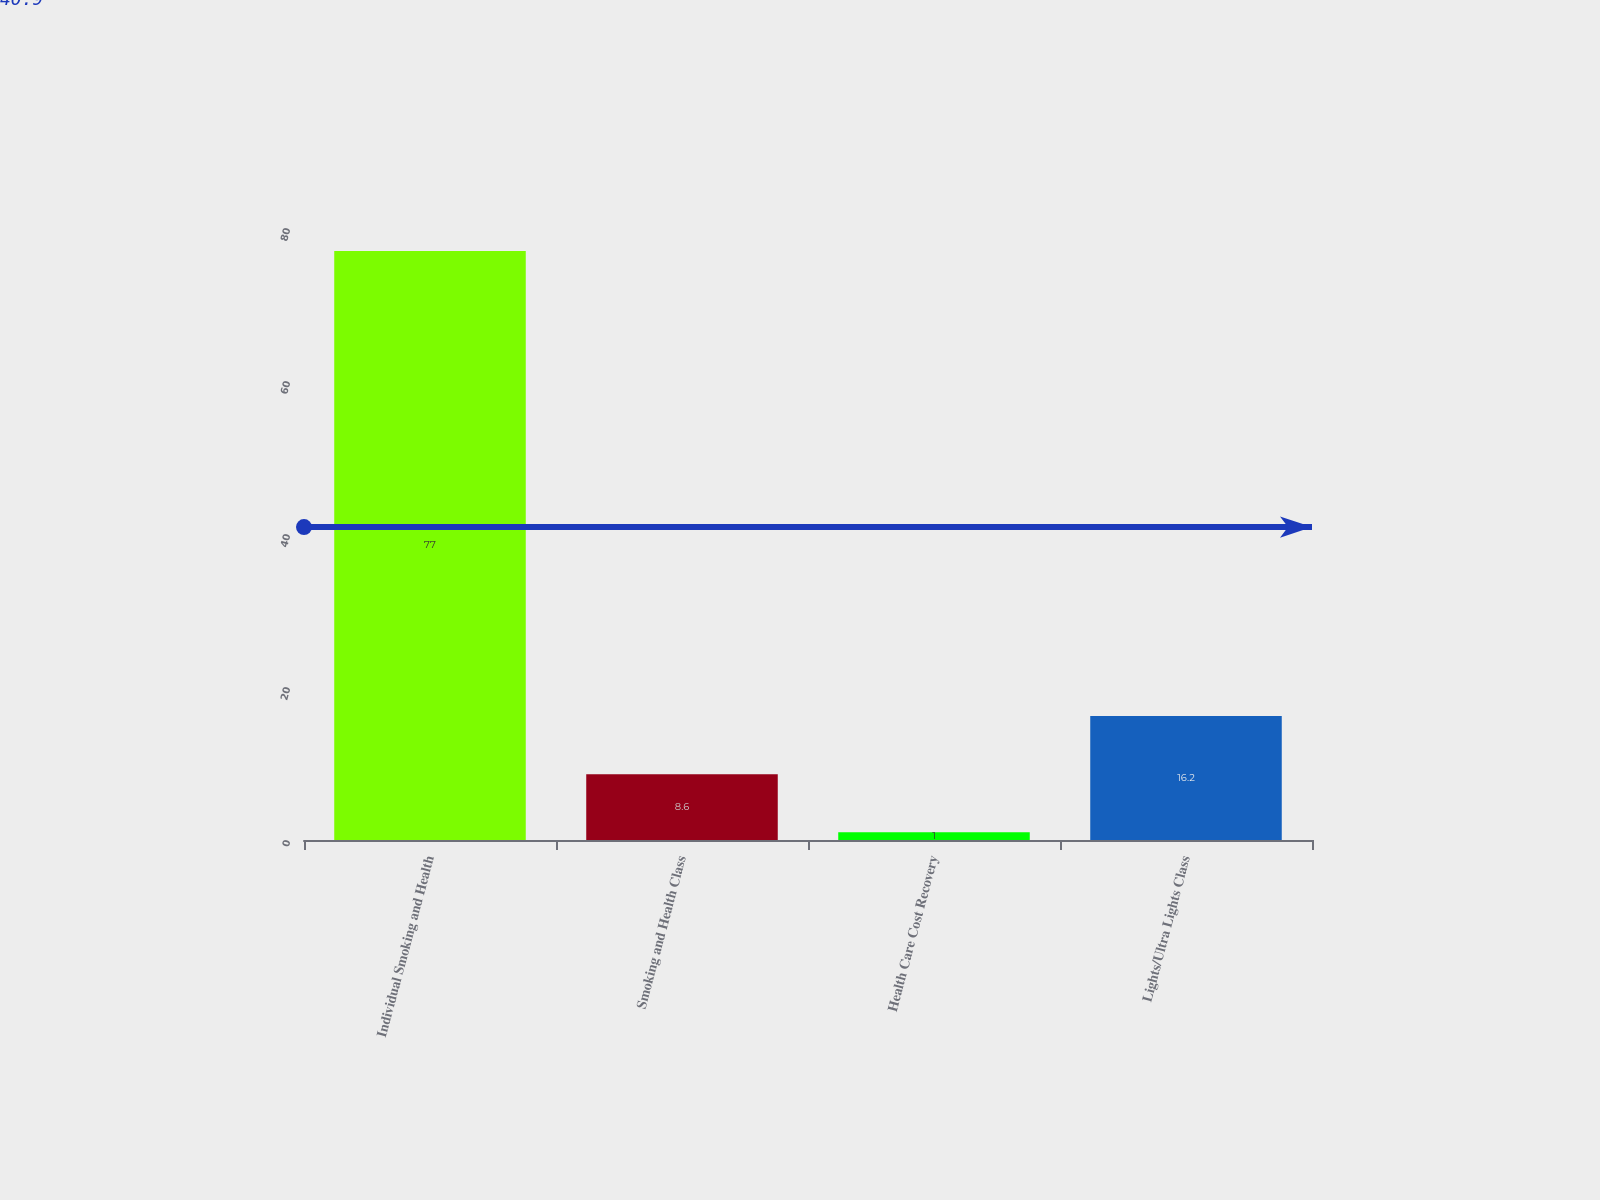Convert chart. <chart><loc_0><loc_0><loc_500><loc_500><bar_chart><fcel>Individual Smoking and Health<fcel>Smoking and Health Class<fcel>Health Care Cost Recovery<fcel>Lights/Ultra Lights Class<nl><fcel>77<fcel>8.6<fcel>1<fcel>16.2<nl></chart> 